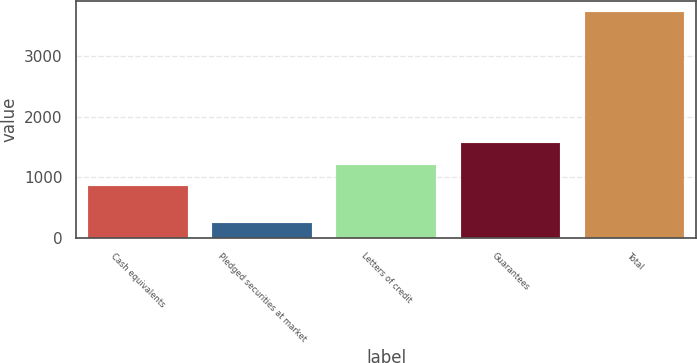Convert chart to OTSL. <chart><loc_0><loc_0><loc_500><loc_500><bar_chart><fcel>Cash equivalents<fcel>Pledged securities at market<fcel>Letters of credit<fcel>Guarantees<fcel>Total<nl><fcel>866<fcel>256<fcel>1212.8<fcel>1559.6<fcel>3724<nl></chart> 